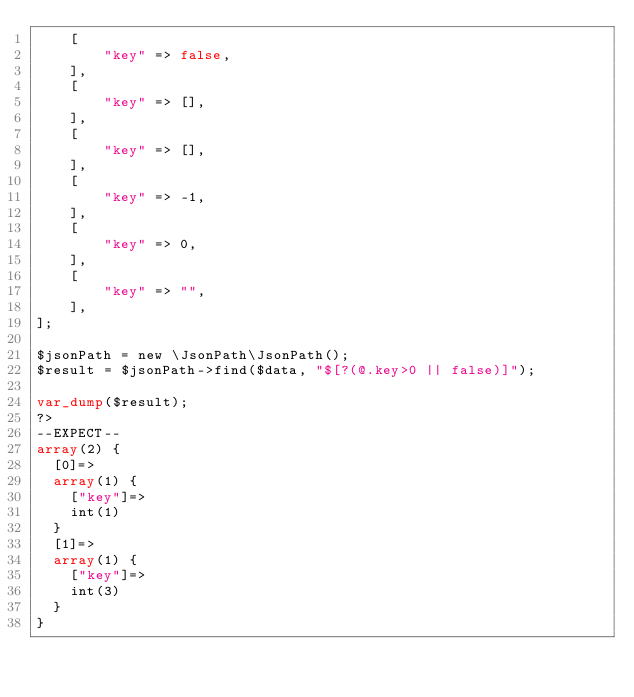Convert code to text. <code><loc_0><loc_0><loc_500><loc_500><_PHP_>    [
        "key" => false,
    ],
    [
        "key" => [],
    ],
    [
        "key" => [],
    ],
    [
        "key" => -1,
    ],
    [
        "key" => 0,
    ],
    [
        "key" => "",
    ],
];

$jsonPath = new \JsonPath\JsonPath();
$result = $jsonPath->find($data, "$[?(@.key>0 || false)]");

var_dump($result);
?>
--EXPECT--
array(2) {
  [0]=>
  array(1) {
    ["key"]=>
    int(1)
  }
  [1]=>
  array(1) {
    ["key"]=>
    int(3)
  }
}</code> 